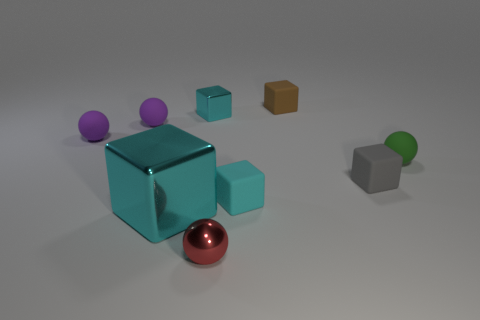Subtract all cyan cylinders. How many cyan cubes are left? 3 Add 1 small green rubber objects. How many objects exist? 10 Subtract all spheres. How many objects are left? 5 Add 2 green balls. How many green balls exist? 3 Subtract 1 green balls. How many objects are left? 8 Subtract all large purple matte blocks. Subtract all cyan rubber objects. How many objects are left? 8 Add 6 cyan things. How many cyan things are left? 9 